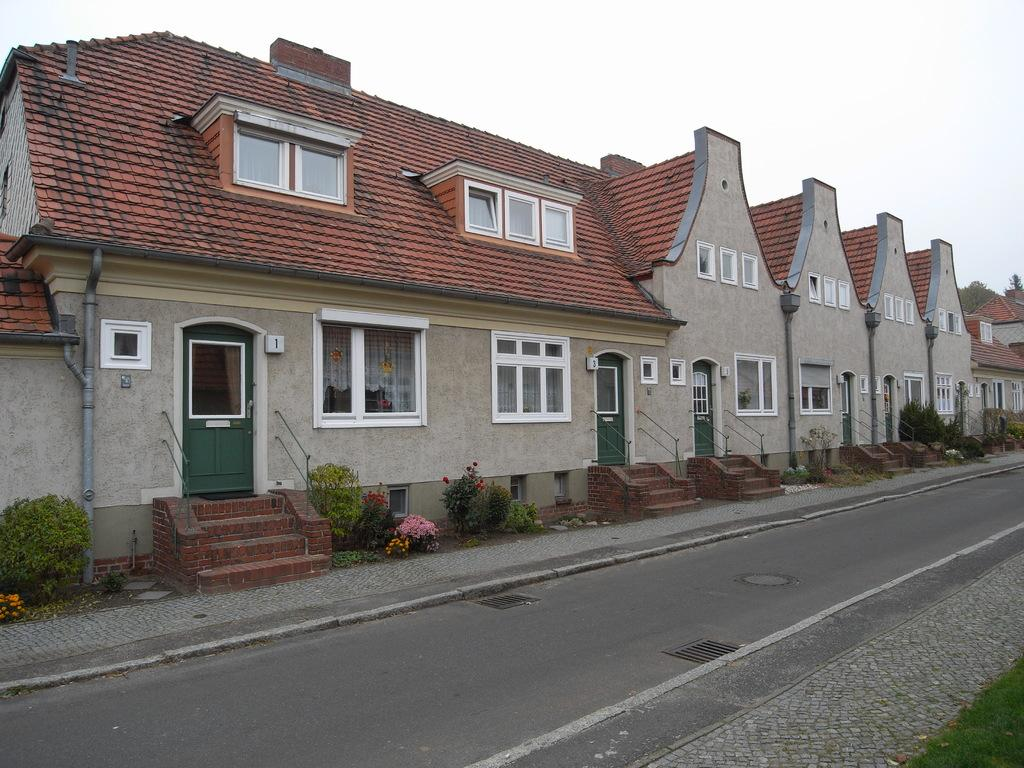What type of structure is visible in the image? There is a building in the image. What architectural feature can be seen near the building? There are stairs in the image. What is in front of the building? There is a road and grass in front of the building. What type of vegetation is present in the image? There are plants, flowers, and trees in the image. What part of the natural environment is visible in the image? The sky is visible in the image. What color is the skin of the person walking on the grass in the image? There is no person visible in the image, so we cannot determine the color of their skin. 